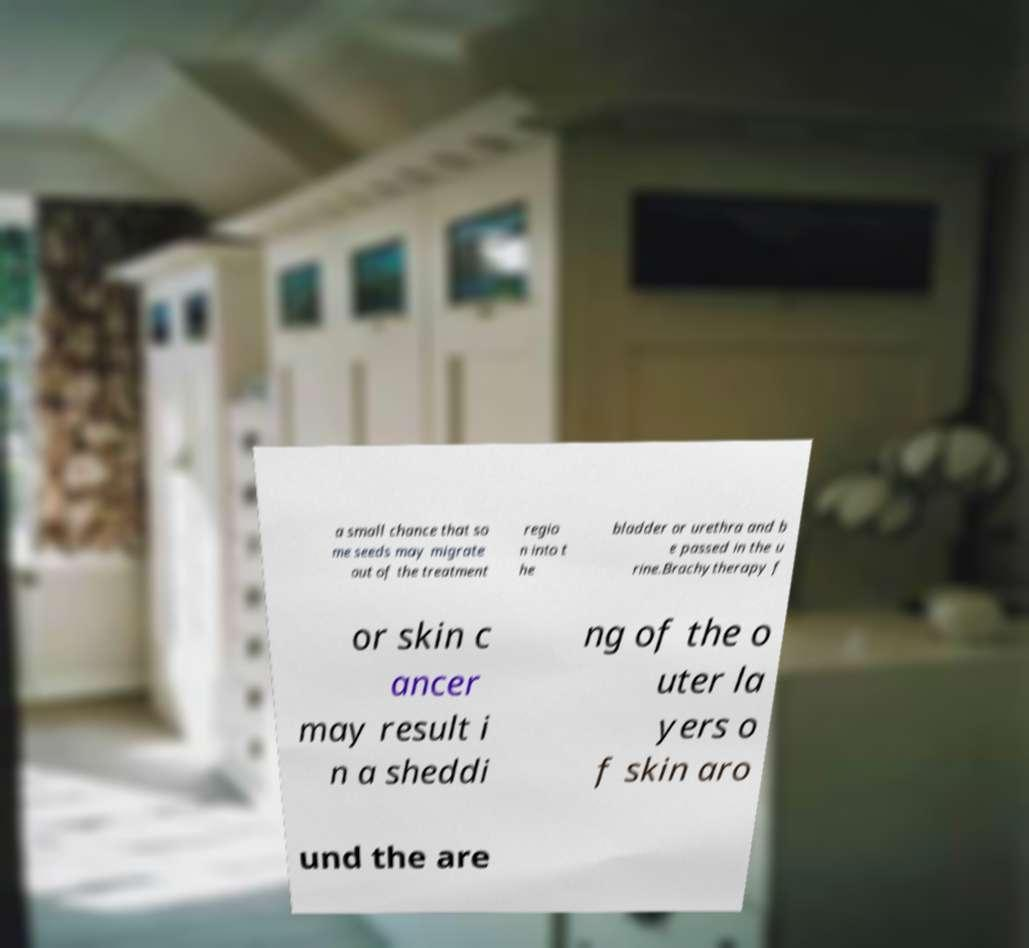Can you accurately transcribe the text from the provided image for me? a small chance that so me seeds may migrate out of the treatment regio n into t he bladder or urethra and b e passed in the u rine.Brachytherapy f or skin c ancer may result i n a sheddi ng of the o uter la yers o f skin aro und the are 